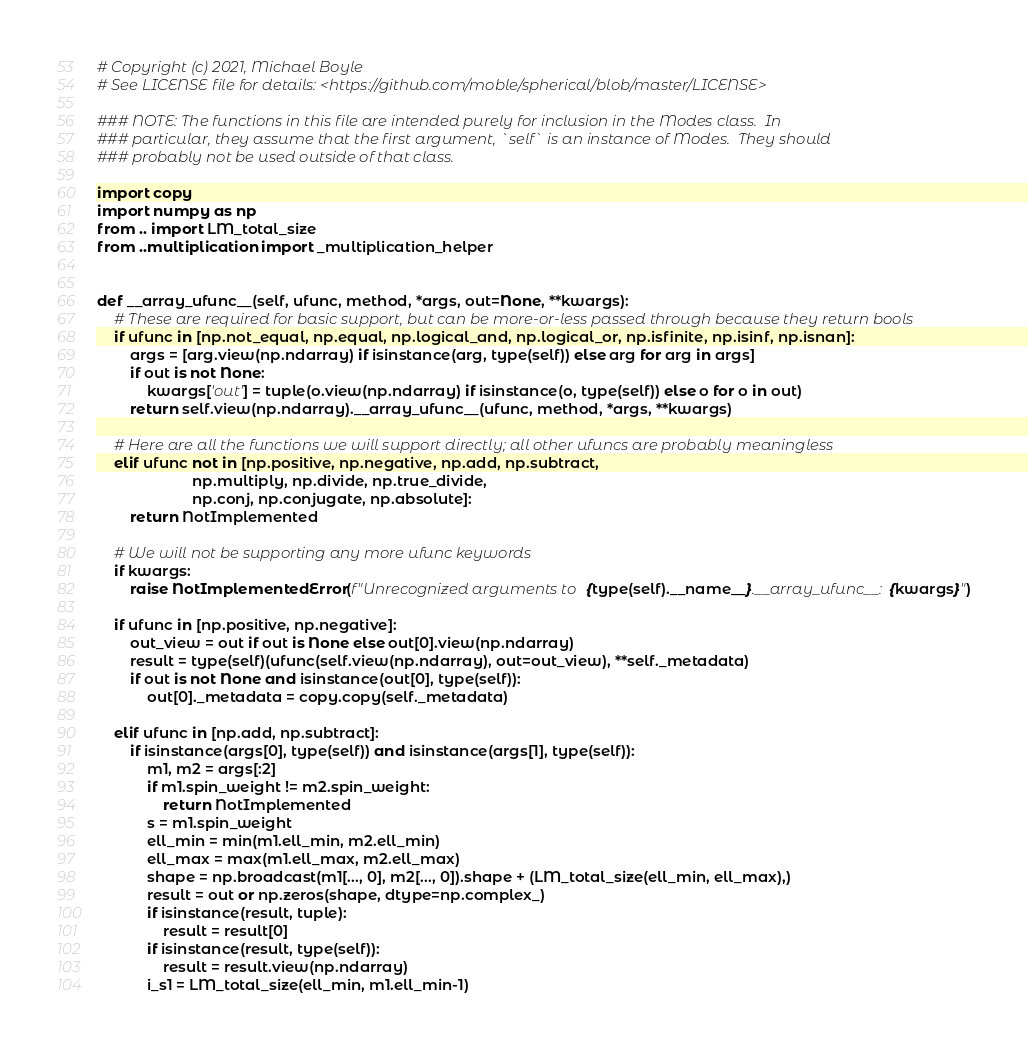<code> <loc_0><loc_0><loc_500><loc_500><_Python_># Copyright (c) 2021, Michael Boyle
# See LICENSE file for details: <https://github.com/moble/spherical/blob/master/LICENSE>

### NOTE: The functions in this file are intended purely for inclusion in the Modes class.  In
### particular, they assume that the first argument, `self` is an instance of Modes.  They should
### probably not be used outside of that class.

import copy
import numpy as np
from .. import LM_total_size
from ..multiplication import _multiplication_helper


def __array_ufunc__(self, ufunc, method, *args, out=None, **kwargs):
    # These are required for basic support, but can be more-or-less passed through because they return bools
    if ufunc in [np.not_equal, np.equal, np.logical_and, np.logical_or, np.isfinite, np.isinf, np.isnan]:
        args = [arg.view(np.ndarray) if isinstance(arg, type(self)) else arg for arg in args]
        if out is not None:
            kwargs['out'] = tuple(o.view(np.ndarray) if isinstance(o, type(self)) else o for o in out)
        return self.view(np.ndarray).__array_ufunc__(ufunc, method, *args, **kwargs)

    # Here are all the functions we will support directly; all other ufuncs are probably meaningless
    elif ufunc not in [np.positive, np.negative, np.add, np.subtract,
                       np.multiply, np.divide, np.true_divide,
                       np.conj, np.conjugate, np.absolute]:
        return NotImplemented

    # We will not be supporting any more ufunc keywords
    if kwargs:
        raise NotImplementedError(f"Unrecognized arguments to {type(self).__name__}.__array_ufunc__: {kwargs}")

    if ufunc in [np.positive, np.negative]:
        out_view = out if out is None else out[0].view(np.ndarray)
        result = type(self)(ufunc(self.view(np.ndarray), out=out_view), **self._metadata)
        if out is not None and isinstance(out[0], type(self)):
            out[0]._metadata = copy.copy(self._metadata)

    elif ufunc in [np.add, np.subtract]:
        if isinstance(args[0], type(self)) and isinstance(args[1], type(self)):
            m1, m2 = args[:2]
            if m1.spin_weight != m2.spin_weight:
                return NotImplemented
            s = m1.spin_weight
            ell_min = min(m1.ell_min, m2.ell_min)
            ell_max = max(m1.ell_max, m2.ell_max)
            shape = np.broadcast(m1[..., 0], m2[..., 0]).shape + (LM_total_size(ell_min, ell_max),)
            result = out or np.zeros(shape, dtype=np.complex_)
            if isinstance(result, tuple):
                result = result[0]
            if isinstance(result, type(self)):
                result = result.view(np.ndarray)
            i_s1 = LM_total_size(ell_min, m1.ell_min-1)</code> 